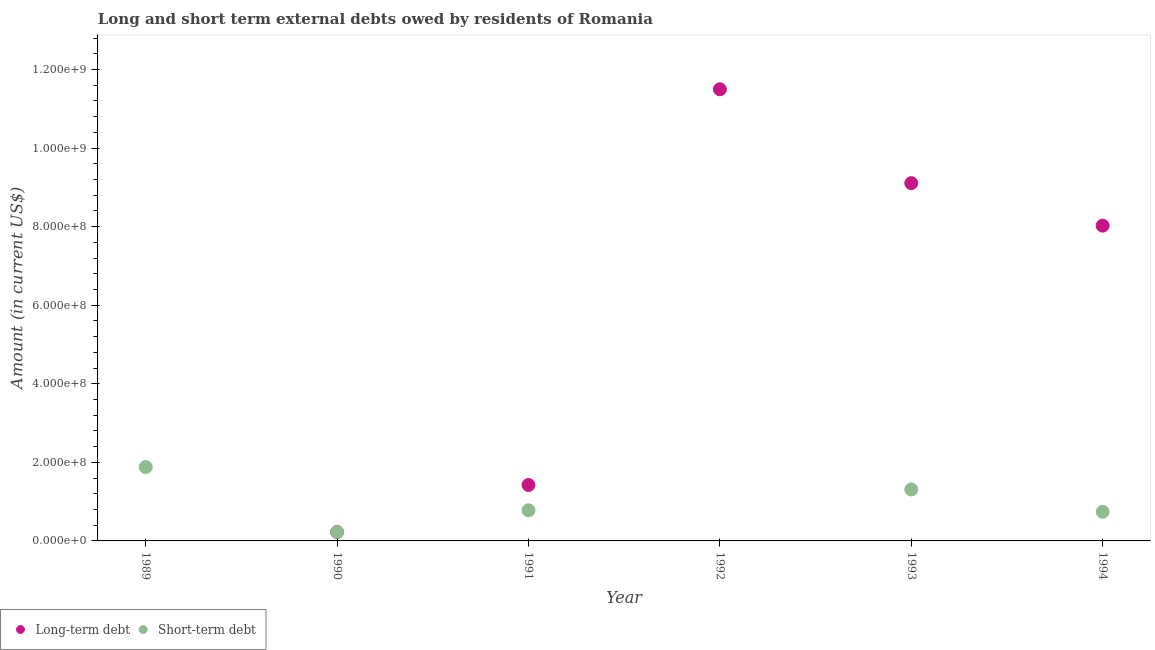Across all years, what is the maximum short-term debts owed by residents?
Offer a terse response. 1.88e+08. Across all years, what is the minimum long-term debts owed by residents?
Your answer should be very brief. 0. What is the total long-term debts owed by residents in the graph?
Offer a very short reply. 3.03e+09. What is the difference between the short-term debts owed by residents in 1991 and that in 1994?
Your response must be concise. 4.00e+06. What is the difference between the short-term debts owed by residents in 1990 and the long-term debts owed by residents in 1992?
Your answer should be compact. -1.13e+09. What is the average short-term debts owed by residents per year?
Make the answer very short. 8.22e+07. In the year 1994, what is the difference between the short-term debts owed by residents and long-term debts owed by residents?
Make the answer very short. -7.28e+08. In how many years, is the long-term debts owed by residents greater than 160000000 US$?
Your response must be concise. 3. What is the ratio of the short-term debts owed by residents in 1989 to that in 1990?
Make the answer very short. 8.55. Is the difference between the short-term debts owed by residents in 1991 and 1994 greater than the difference between the long-term debts owed by residents in 1991 and 1994?
Your response must be concise. Yes. What is the difference between the highest and the second highest short-term debts owed by residents?
Give a very brief answer. 5.70e+07. What is the difference between the highest and the lowest long-term debts owed by residents?
Offer a very short reply. 1.15e+09. Are the values on the major ticks of Y-axis written in scientific E-notation?
Provide a succinct answer. Yes. Does the graph contain grids?
Provide a succinct answer. No. How are the legend labels stacked?
Your response must be concise. Horizontal. What is the title of the graph?
Offer a terse response. Long and short term external debts owed by residents of Romania. Does "Electricity and heat production" appear as one of the legend labels in the graph?
Make the answer very short. No. What is the label or title of the X-axis?
Your response must be concise. Year. What is the label or title of the Y-axis?
Give a very brief answer. Amount (in current US$). What is the Amount (in current US$) of Long-term debt in 1989?
Give a very brief answer. 0. What is the Amount (in current US$) in Short-term debt in 1989?
Offer a very short reply. 1.88e+08. What is the Amount (in current US$) of Long-term debt in 1990?
Ensure brevity in your answer.  2.25e+07. What is the Amount (in current US$) of Short-term debt in 1990?
Your answer should be compact. 2.20e+07. What is the Amount (in current US$) in Long-term debt in 1991?
Keep it short and to the point. 1.42e+08. What is the Amount (in current US$) in Short-term debt in 1991?
Your response must be concise. 7.80e+07. What is the Amount (in current US$) in Long-term debt in 1992?
Give a very brief answer. 1.15e+09. What is the Amount (in current US$) in Long-term debt in 1993?
Your answer should be compact. 9.11e+08. What is the Amount (in current US$) of Short-term debt in 1993?
Provide a succinct answer. 1.31e+08. What is the Amount (in current US$) in Long-term debt in 1994?
Provide a succinct answer. 8.02e+08. What is the Amount (in current US$) of Short-term debt in 1994?
Your response must be concise. 7.40e+07. Across all years, what is the maximum Amount (in current US$) in Long-term debt?
Make the answer very short. 1.15e+09. Across all years, what is the maximum Amount (in current US$) of Short-term debt?
Ensure brevity in your answer.  1.88e+08. Across all years, what is the minimum Amount (in current US$) of Long-term debt?
Provide a short and direct response. 0. What is the total Amount (in current US$) of Long-term debt in the graph?
Your response must be concise. 3.03e+09. What is the total Amount (in current US$) of Short-term debt in the graph?
Ensure brevity in your answer.  4.93e+08. What is the difference between the Amount (in current US$) of Short-term debt in 1989 and that in 1990?
Provide a succinct answer. 1.66e+08. What is the difference between the Amount (in current US$) in Short-term debt in 1989 and that in 1991?
Offer a terse response. 1.10e+08. What is the difference between the Amount (in current US$) of Short-term debt in 1989 and that in 1993?
Make the answer very short. 5.70e+07. What is the difference between the Amount (in current US$) of Short-term debt in 1989 and that in 1994?
Keep it short and to the point. 1.14e+08. What is the difference between the Amount (in current US$) in Long-term debt in 1990 and that in 1991?
Provide a succinct answer. -1.20e+08. What is the difference between the Amount (in current US$) of Short-term debt in 1990 and that in 1991?
Your answer should be compact. -5.60e+07. What is the difference between the Amount (in current US$) of Long-term debt in 1990 and that in 1992?
Your answer should be compact. -1.13e+09. What is the difference between the Amount (in current US$) in Long-term debt in 1990 and that in 1993?
Provide a short and direct response. -8.88e+08. What is the difference between the Amount (in current US$) of Short-term debt in 1990 and that in 1993?
Your response must be concise. -1.09e+08. What is the difference between the Amount (in current US$) of Long-term debt in 1990 and that in 1994?
Offer a terse response. -7.80e+08. What is the difference between the Amount (in current US$) of Short-term debt in 1990 and that in 1994?
Offer a very short reply. -5.20e+07. What is the difference between the Amount (in current US$) in Long-term debt in 1991 and that in 1992?
Your answer should be compact. -1.01e+09. What is the difference between the Amount (in current US$) in Long-term debt in 1991 and that in 1993?
Your response must be concise. -7.68e+08. What is the difference between the Amount (in current US$) of Short-term debt in 1991 and that in 1993?
Offer a very short reply. -5.30e+07. What is the difference between the Amount (in current US$) in Long-term debt in 1991 and that in 1994?
Your answer should be compact. -6.60e+08. What is the difference between the Amount (in current US$) in Short-term debt in 1991 and that in 1994?
Make the answer very short. 4.00e+06. What is the difference between the Amount (in current US$) in Long-term debt in 1992 and that in 1993?
Keep it short and to the point. 2.39e+08. What is the difference between the Amount (in current US$) in Long-term debt in 1992 and that in 1994?
Provide a short and direct response. 3.47e+08. What is the difference between the Amount (in current US$) in Long-term debt in 1993 and that in 1994?
Your answer should be very brief. 1.08e+08. What is the difference between the Amount (in current US$) in Short-term debt in 1993 and that in 1994?
Offer a very short reply. 5.70e+07. What is the difference between the Amount (in current US$) in Long-term debt in 1990 and the Amount (in current US$) in Short-term debt in 1991?
Provide a short and direct response. -5.55e+07. What is the difference between the Amount (in current US$) of Long-term debt in 1990 and the Amount (in current US$) of Short-term debt in 1993?
Give a very brief answer. -1.09e+08. What is the difference between the Amount (in current US$) of Long-term debt in 1990 and the Amount (in current US$) of Short-term debt in 1994?
Ensure brevity in your answer.  -5.15e+07. What is the difference between the Amount (in current US$) of Long-term debt in 1991 and the Amount (in current US$) of Short-term debt in 1993?
Give a very brief answer. 1.14e+07. What is the difference between the Amount (in current US$) in Long-term debt in 1991 and the Amount (in current US$) in Short-term debt in 1994?
Offer a terse response. 6.84e+07. What is the difference between the Amount (in current US$) of Long-term debt in 1992 and the Amount (in current US$) of Short-term debt in 1993?
Your answer should be compact. 1.02e+09. What is the difference between the Amount (in current US$) in Long-term debt in 1992 and the Amount (in current US$) in Short-term debt in 1994?
Give a very brief answer. 1.08e+09. What is the difference between the Amount (in current US$) of Long-term debt in 1993 and the Amount (in current US$) of Short-term debt in 1994?
Keep it short and to the point. 8.37e+08. What is the average Amount (in current US$) of Long-term debt per year?
Your answer should be very brief. 5.05e+08. What is the average Amount (in current US$) of Short-term debt per year?
Your response must be concise. 8.22e+07. In the year 1990, what is the difference between the Amount (in current US$) in Long-term debt and Amount (in current US$) in Short-term debt?
Make the answer very short. 4.99e+05. In the year 1991, what is the difference between the Amount (in current US$) of Long-term debt and Amount (in current US$) of Short-term debt?
Offer a terse response. 6.44e+07. In the year 1993, what is the difference between the Amount (in current US$) in Long-term debt and Amount (in current US$) in Short-term debt?
Provide a short and direct response. 7.80e+08. In the year 1994, what is the difference between the Amount (in current US$) of Long-term debt and Amount (in current US$) of Short-term debt?
Your answer should be compact. 7.28e+08. What is the ratio of the Amount (in current US$) in Short-term debt in 1989 to that in 1990?
Your response must be concise. 8.55. What is the ratio of the Amount (in current US$) in Short-term debt in 1989 to that in 1991?
Ensure brevity in your answer.  2.41. What is the ratio of the Amount (in current US$) of Short-term debt in 1989 to that in 1993?
Your response must be concise. 1.44. What is the ratio of the Amount (in current US$) of Short-term debt in 1989 to that in 1994?
Your response must be concise. 2.54. What is the ratio of the Amount (in current US$) of Long-term debt in 1990 to that in 1991?
Your response must be concise. 0.16. What is the ratio of the Amount (in current US$) in Short-term debt in 1990 to that in 1991?
Make the answer very short. 0.28. What is the ratio of the Amount (in current US$) of Long-term debt in 1990 to that in 1992?
Your response must be concise. 0.02. What is the ratio of the Amount (in current US$) in Long-term debt in 1990 to that in 1993?
Give a very brief answer. 0.02. What is the ratio of the Amount (in current US$) in Short-term debt in 1990 to that in 1993?
Your answer should be compact. 0.17. What is the ratio of the Amount (in current US$) in Long-term debt in 1990 to that in 1994?
Provide a succinct answer. 0.03. What is the ratio of the Amount (in current US$) in Short-term debt in 1990 to that in 1994?
Offer a terse response. 0.3. What is the ratio of the Amount (in current US$) of Long-term debt in 1991 to that in 1992?
Your answer should be very brief. 0.12. What is the ratio of the Amount (in current US$) of Long-term debt in 1991 to that in 1993?
Provide a short and direct response. 0.16. What is the ratio of the Amount (in current US$) in Short-term debt in 1991 to that in 1993?
Your answer should be compact. 0.6. What is the ratio of the Amount (in current US$) in Long-term debt in 1991 to that in 1994?
Your response must be concise. 0.18. What is the ratio of the Amount (in current US$) in Short-term debt in 1991 to that in 1994?
Provide a short and direct response. 1.05. What is the ratio of the Amount (in current US$) in Long-term debt in 1992 to that in 1993?
Keep it short and to the point. 1.26. What is the ratio of the Amount (in current US$) of Long-term debt in 1992 to that in 1994?
Provide a short and direct response. 1.43. What is the ratio of the Amount (in current US$) in Long-term debt in 1993 to that in 1994?
Provide a short and direct response. 1.13. What is the ratio of the Amount (in current US$) in Short-term debt in 1993 to that in 1994?
Offer a terse response. 1.77. What is the difference between the highest and the second highest Amount (in current US$) of Long-term debt?
Ensure brevity in your answer.  2.39e+08. What is the difference between the highest and the second highest Amount (in current US$) in Short-term debt?
Your answer should be very brief. 5.70e+07. What is the difference between the highest and the lowest Amount (in current US$) of Long-term debt?
Offer a terse response. 1.15e+09. What is the difference between the highest and the lowest Amount (in current US$) of Short-term debt?
Give a very brief answer. 1.88e+08. 